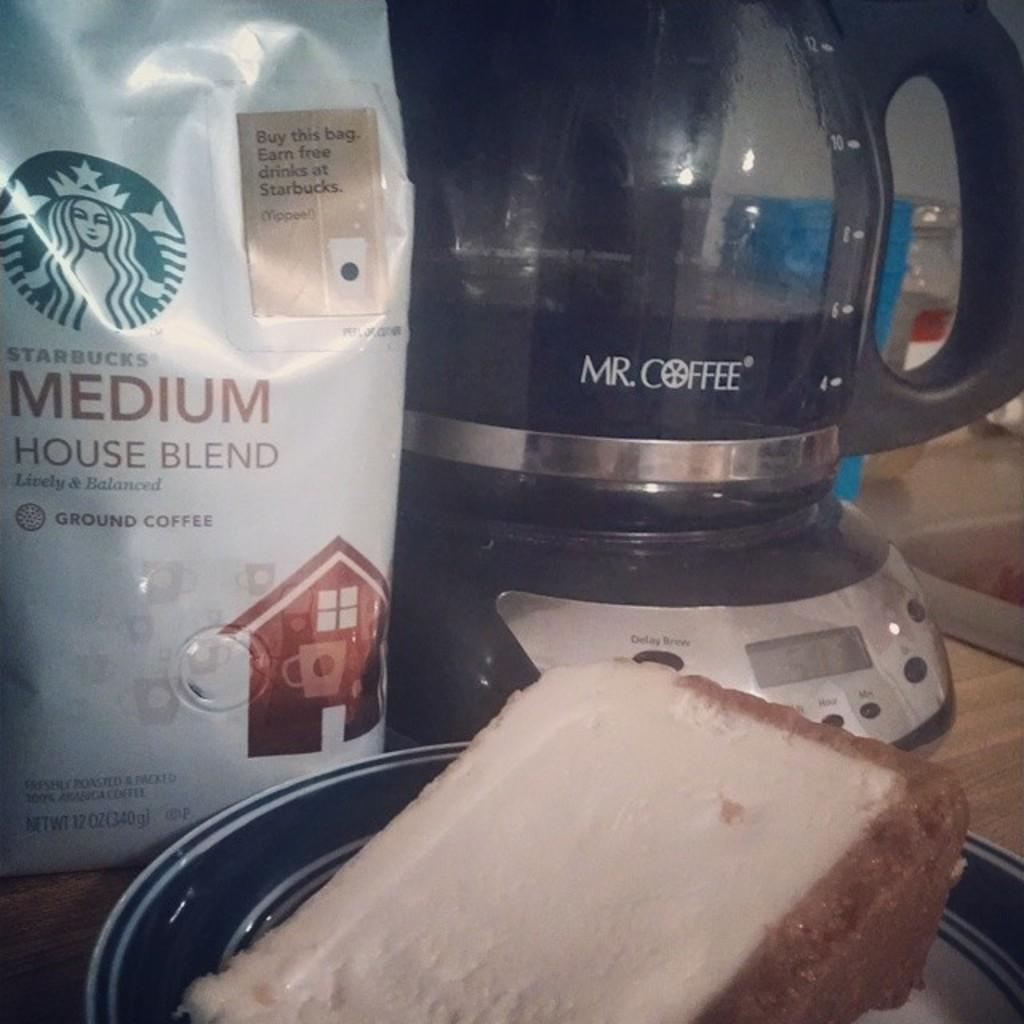<image>
Present a compact description of the photo's key features. Mr coffee pot and a bag of Star Bucks medium house blend ground coffee. 